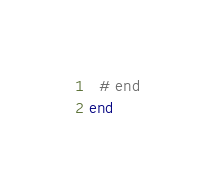Convert code to text. <code><loc_0><loc_0><loc_500><loc_500><_Ruby_>  # end
end
</code> 